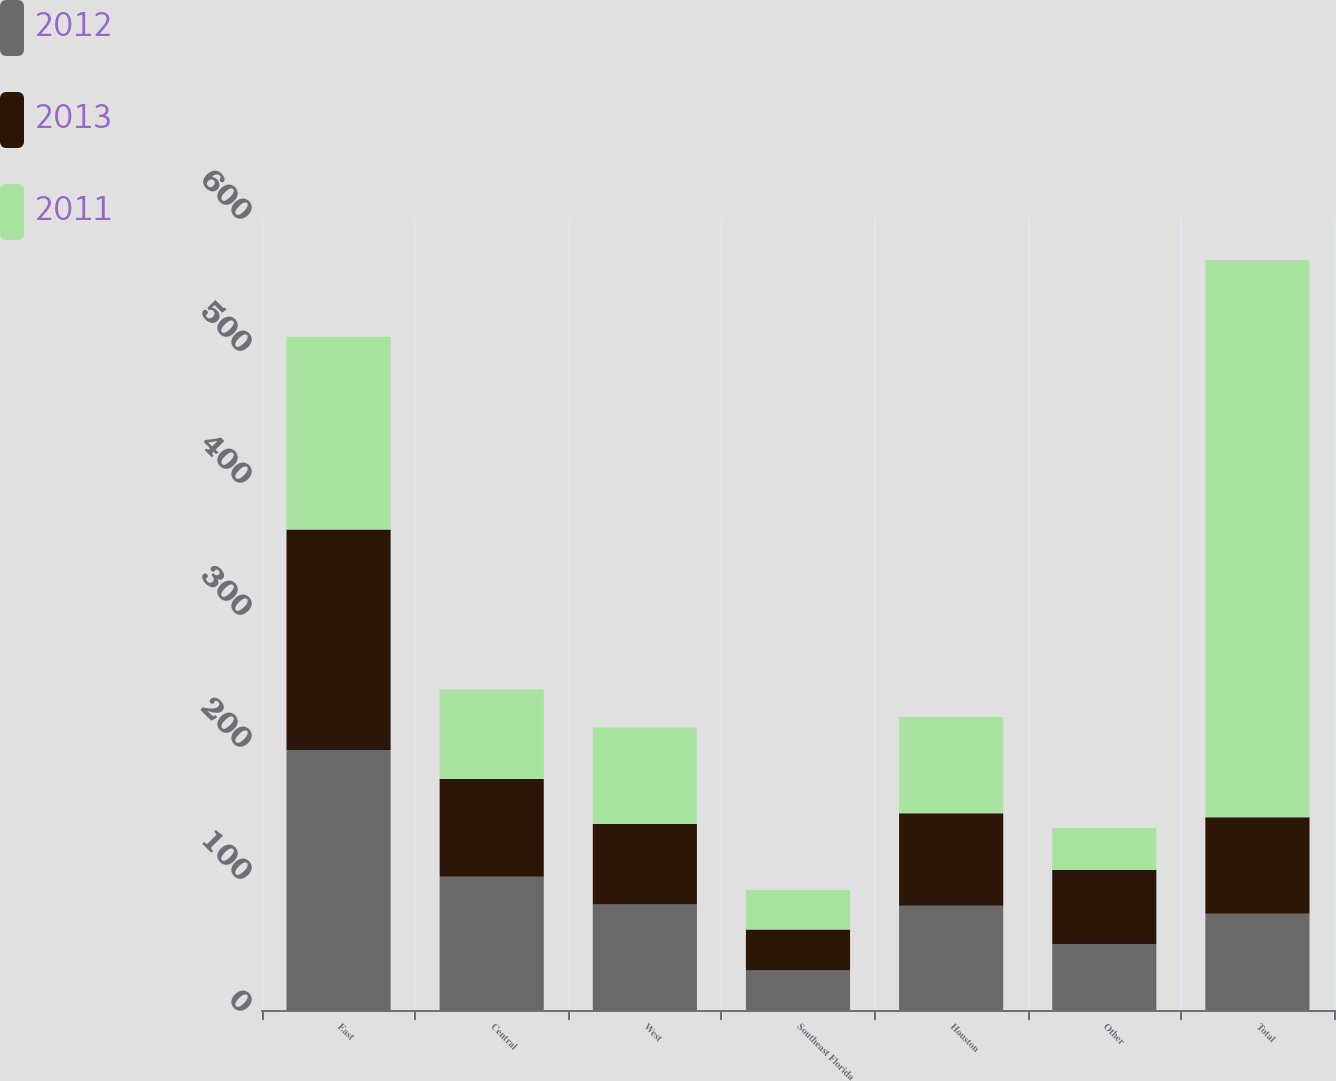<chart> <loc_0><loc_0><loc_500><loc_500><stacked_bar_chart><ecel><fcel>East<fcel>Central<fcel>West<fcel>Southeast Florida<fcel>Houston<fcel>Other<fcel>Total<nl><fcel>2012<fcel>197<fcel>101<fcel>80<fcel>30<fcel>79<fcel>50<fcel>73<nl><fcel>2013<fcel>167<fcel>74<fcel>61<fcel>31<fcel>70<fcel>56<fcel>73<nl><fcel>2011<fcel>146<fcel>68<fcel>73<fcel>30<fcel>73<fcel>32<fcel>422<nl></chart> 